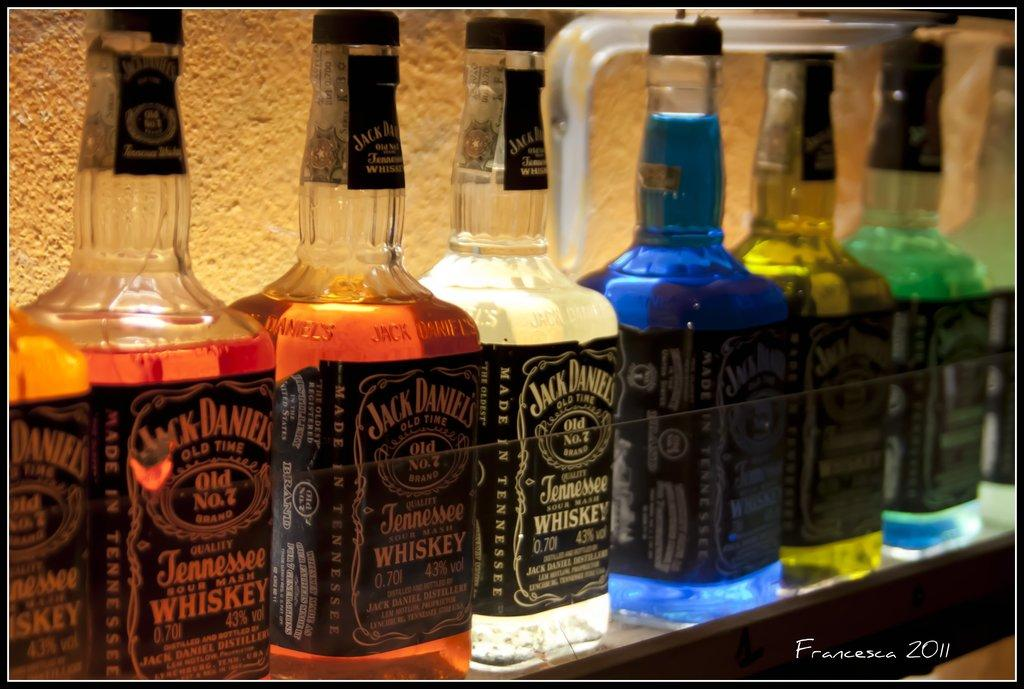<image>
Relay a brief, clear account of the picture shown. A number of bottles of Jack Daniels whiskey in different colours 